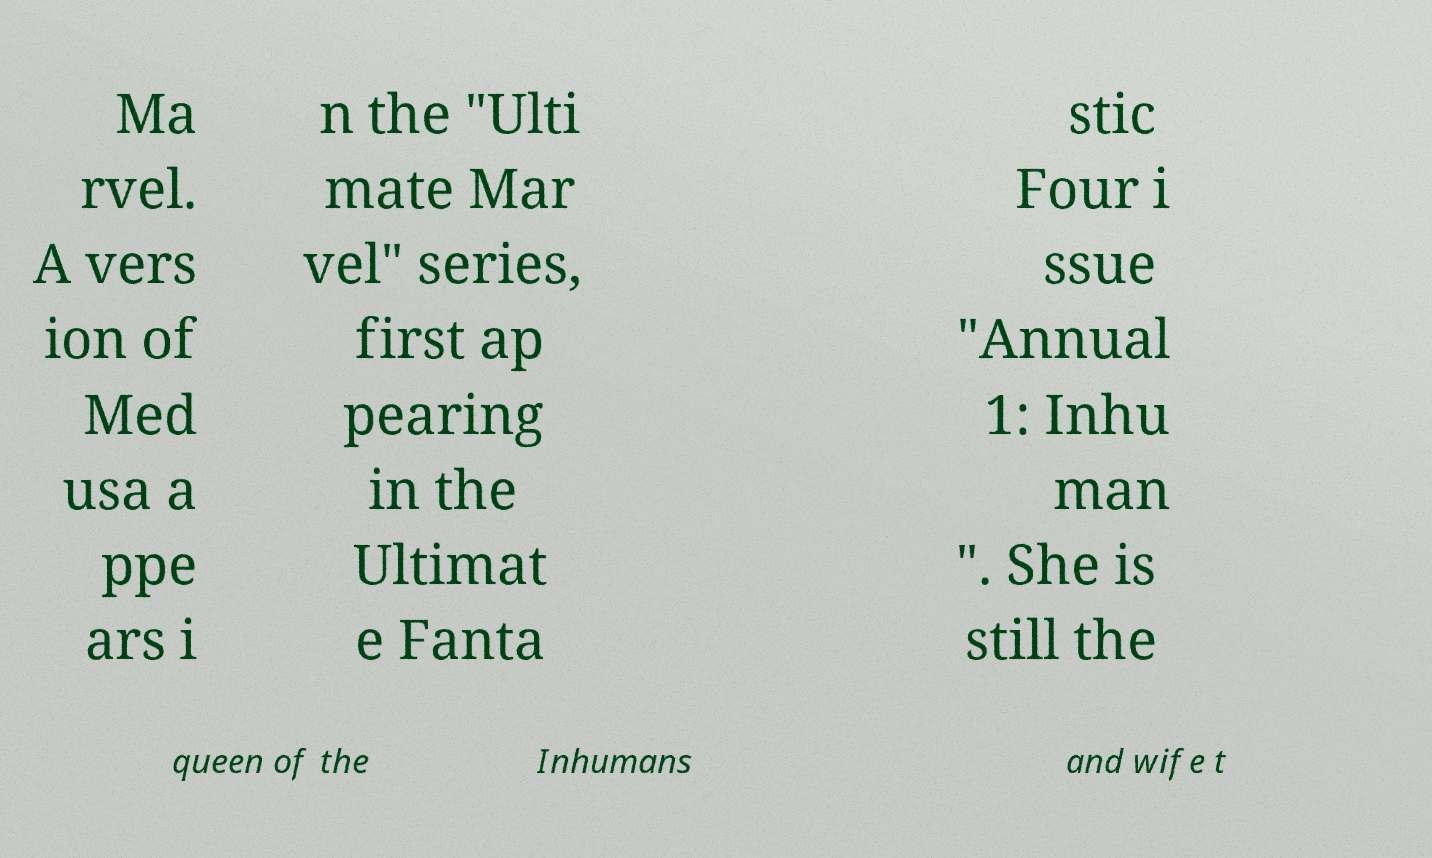What messages or text are displayed in this image? I need them in a readable, typed format. Ma rvel. A vers ion of Med usa a ppe ars i n the "Ulti mate Mar vel" series, first ap pearing in the Ultimat e Fanta stic Four i ssue "Annual 1: Inhu man ". She is still the queen of the Inhumans and wife t 